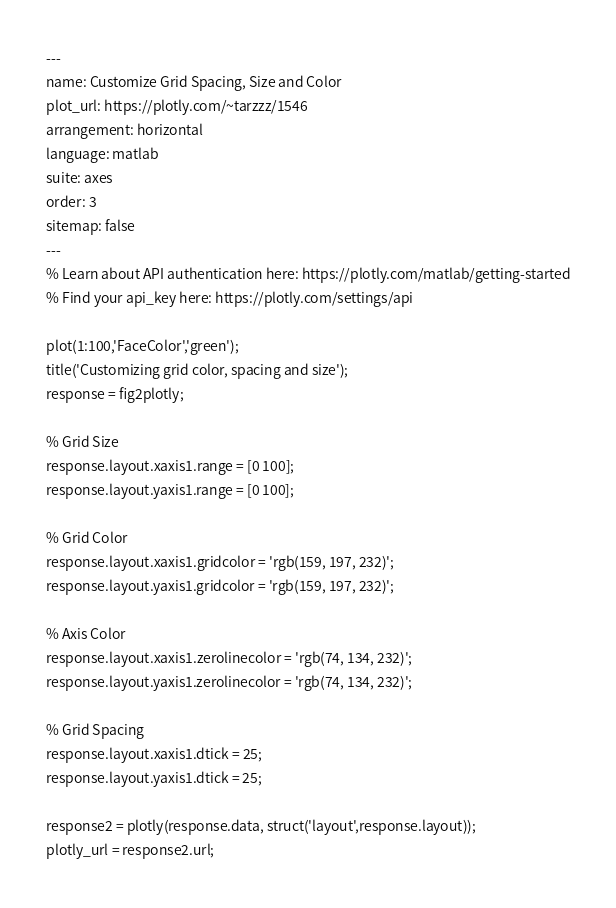Convert code to text. <code><loc_0><loc_0><loc_500><loc_500><_HTML_>---
name: Customize Grid Spacing, Size and Color
plot_url: https://plotly.com/~tarzzz/1546
arrangement: horizontal
language: matlab
suite: axes
order: 3
sitemap: false
---
% Learn about API authentication here: https://plotly.com/matlab/getting-started
% Find your api_key here: https://plotly.com/settings/api

plot(1:100,'FaceColor','green');
title('Customizing grid color, spacing and size');
response = fig2plotly;

% Grid Size
response.layout.xaxis1.range = [0 100];
response.layout.yaxis1.range = [0 100];

% Grid Color
response.layout.xaxis1.gridcolor = 'rgb(159, 197, 232)';
response.layout.yaxis1.gridcolor = 'rgb(159, 197, 232)';

% Axis Color
response.layout.xaxis1.zerolinecolor = 'rgb(74, 134, 232)';
response.layout.yaxis1.zerolinecolor = 'rgb(74, 134, 232)';

% Grid Spacing
response.layout.xaxis1.dtick = 25;
response.layout.yaxis1.dtick = 25;

response2 = plotly(response.data, struct('layout',response.layout));
plotly_url = response2.url;</code> 